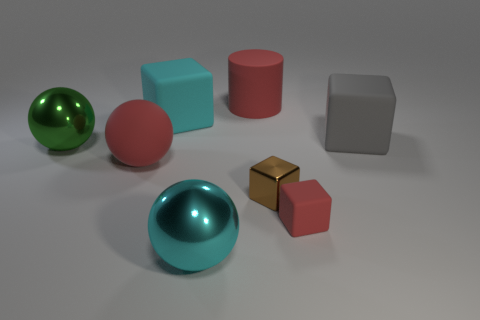Is the material of the large cyan cube the same as the small brown block?
Keep it short and to the point. No. What number of large green shiny things are in front of the big green ball behind the brown object?
Offer a terse response. 0. Are there any gray things that have the same shape as the tiny red matte thing?
Give a very brief answer. Yes. Do the large red thing behind the big matte sphere and the big cyan thing that is behind the gray thing have the same shape?
Offer a terse response. No. What is the shape of the thing that is in front of the tiny metallic thing and on the left side of the small matte object?
Ensure brevity in your answer.  Sphere. Are there any brown metal things that have the same size as the rubber cylinder?
Keep it short and to the point. No. There is a big cylinder; does it have the same color as the large metallic ball left of the large cyan rubber cube?
Your answer should be very brief. No. What is the red cylinder made of?
Your answer should be very brief. Rubber. There is a block to the left of the rubber cylinder; what color is it?
Provide a succinct answer. Cyan. How many big cylinders have the same color as the small rubber cube?
Your response must be concise. 1. 